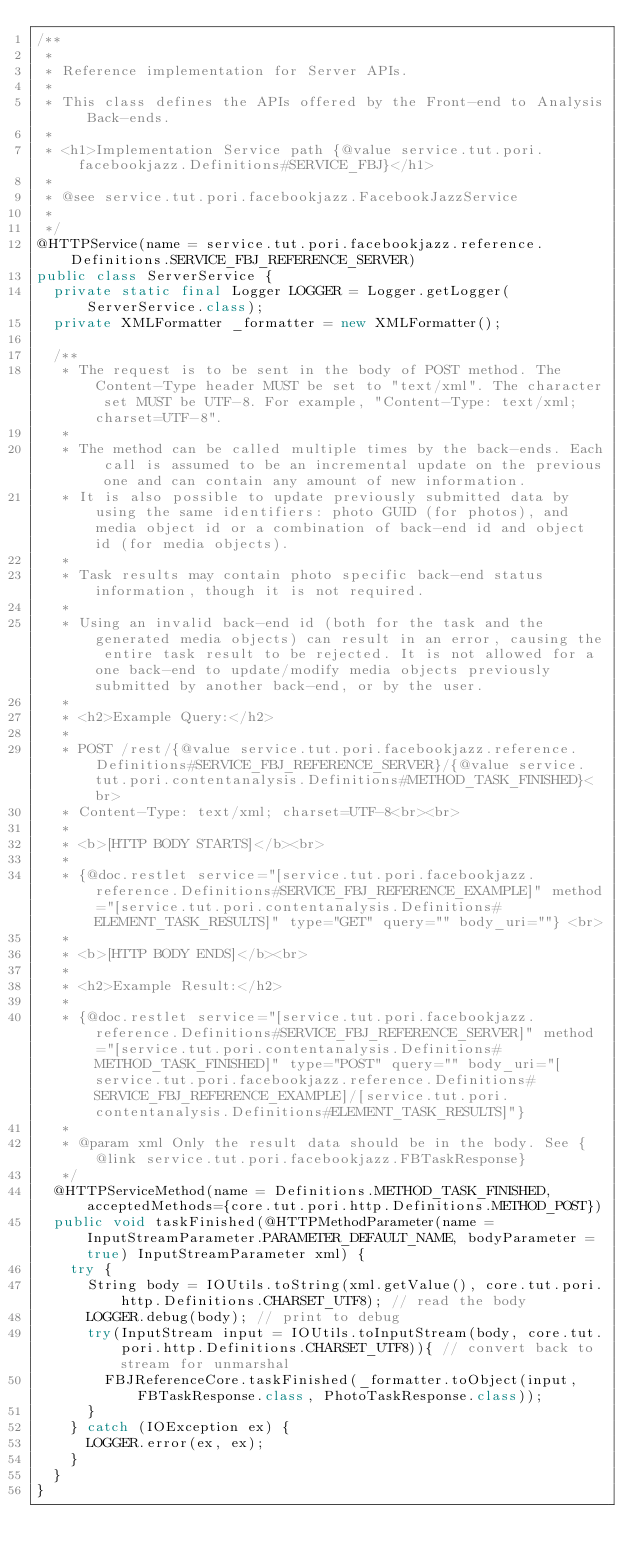<code> <loc_0><loc_0><loc_500><loc_500><_Java_>/**
 * 
 * Reference implementation for Server APIs.
 * 
 * This class defines the APIs offered by the Front-end to Analysis Back-ends.
 * 
 * <h1>Implementation Service path {@value service.tut.pori.facebookjazz.Definitions#SERVICE_FBJ}</h1>
 * 
 * @see service.tut.pori.facebookjazz.FacebookJazzService
 *
 */
@HTTPService(name = service.tut.pori.facebookjazz.reference.Definitions.SERVICE_FBJ_REFERENCE_SERVER)
public class ServerService {
	private static final Logger LOGGER = Logger.getLogger(ServerService.class);
	private XMLFormatter _formatter = new XMLFormatter();
	
	/**
	 * The request is to be sent in the body of POST method. The Content-Type header MUST be set to "text/xml". The character set MUST be UTF-8. For example, "Content-Type: text/xml; charset=UTF-8".
	 * 
	 * The method can be called multiple times by the back-ends. Each call is assumed to be an incremental update on the previous one and can contain any amount of new information. 
	 * It is also possible to update previously submitted data by using the same identifiers: photo GUID (for photos), and media object id or a combination of back-end id and object id (for media objects).
	 * 
	 * Task results may contain photo specific back-end status information, though it is not required.
	 * 
	 * Using an invalid back-end id (both for the task and the generated media objects) can result in an error, causing the entire task result to be rejected. It is not allowed for a one back-end to update/modify media objects previously submitted by another back-end, or by the user.
	 * 
	 * <h2>Example Query:</h2>
	 *
	 * POST /rest/{@value service.tut.pori.facebookjazz.reference.Definitions#SERVICE_FBJ_REFERENCE_SERVER}/{@value service.tut.pori.contentanalysis.Definitions#METHOD_TASK_FINISHED}<br>
	 * Content-Type: text/xml; charset=UTF-8<br><br>
	 *
	 * <b>[HTTP BODY STARTS]</b><br>
	 * 
	 * {@doc.restlet service="[service.tut.pori.facebookjazz.reference.Definitions#SERVICE_FBJ_REFERENCE_EXAMPLE]" method="[service.tut.pori.contentanalysis.Definitions#ELEMENT_TASK_RESULTS]" type="GET" query="" body_uri=""} <br>
	 * 
	 * <b>[HTTP BODY ENDS]</b><br>
	 *
	 * <h2>Example Result:</h2>
	 * 
	 * {@doc.restlet service="[service.tut.pori.facebookjazz.reference.Definitions#SERVICE_FBJ_REFERENCE_SERVER]" method="[service.tut.pori.contentanalysis.Definitions#METHOD_TASK_FINISHED]" type="POST" query="" body_uri="[service.tut.pori.facebookjazz.reference.Definitions#SERVICE_FBJ_REFERENCE_EXAMPLE]/[service.tut.pori.contentanalysis.Definitions#ELEMENT_TASK_RESULTS]"}
	 * 
	 * @param xml Only the result data should be in the body. See {@link service.tut.pori.facebookjazz.FBTaskResponse}
	 */
	@HTTPServiceMethod(name = Definitions.METHOD_TASK_FINISHED, acceptedMethods={core.tut.pori.http.Definitions.METHOD_POST})
	public void taskFinished(@HTTPMethodParameter(name = InputStreamParameter.PARAMETER_DEFAULT_NAME, bodyParameter = true) InputStreamParameter xml) {
		try {
			String body = IOUtils.toString(xml.getValue(), core.tut.pori.http.Definitions.CHARSET_UTF8); // read the body
			LOGGER.debug(body); // print to debug
			try(InputStream input = IOUtils.toInputStream(body, core.tut.pori.http.Definitions.CHARSET_UTF8)){ // convert back to stream for unmarshal
				FBJReferenceCore.taskFinished(_formatter.toObject(input, FBTaskResponse.class, PhotoTaskResponse.class));
			}
		} catch (IOException ex) {
			LOGGER.error(ex, ex);
		}
	}
}
</code> 